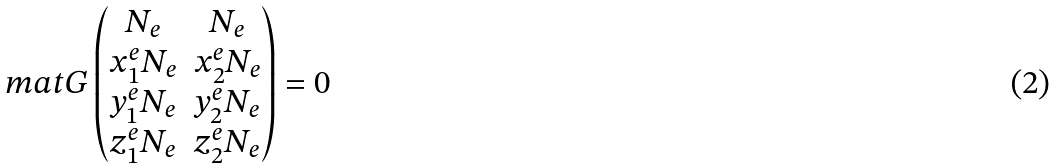<formula> <loc_0><loc_0><loc_500><loc_500>\ m a t G \begin{pmatrix} N _ { e } & N _ { e } \\ x ^ { e } _ { 1 } N _ { e } & x ^ { e } _ { 2 } N _ { e } \\ y ^ { e } _ { 1 } N _ { e } & y ^ { e } _ { 2 } N _ { e } \\ z ^ { e } _ { 1 } N _ { e } & z ^ { e } _ { 2 } N _ { e } \end{pmatrix} = 0</formula> 